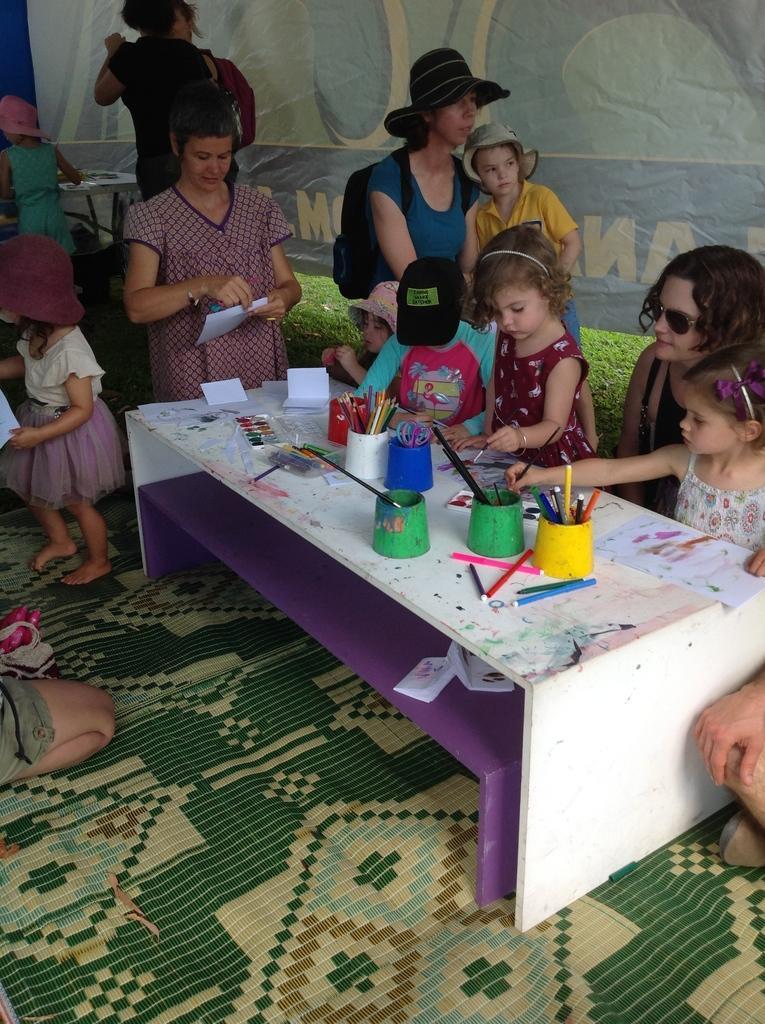In one or two sentences, can you explain what this image depicts? In the picture there are some people and children. In the middle of the picture there a table and woman sitting on chair holding girl and one girl is standing and painting picture beside that girl a boy is sitting with black cap behind him one woman is standing with the hat and standing with child. And behind her there are some people standing and talking beside to it one girl is standing and holding a paper. The table is placed on carpet. 